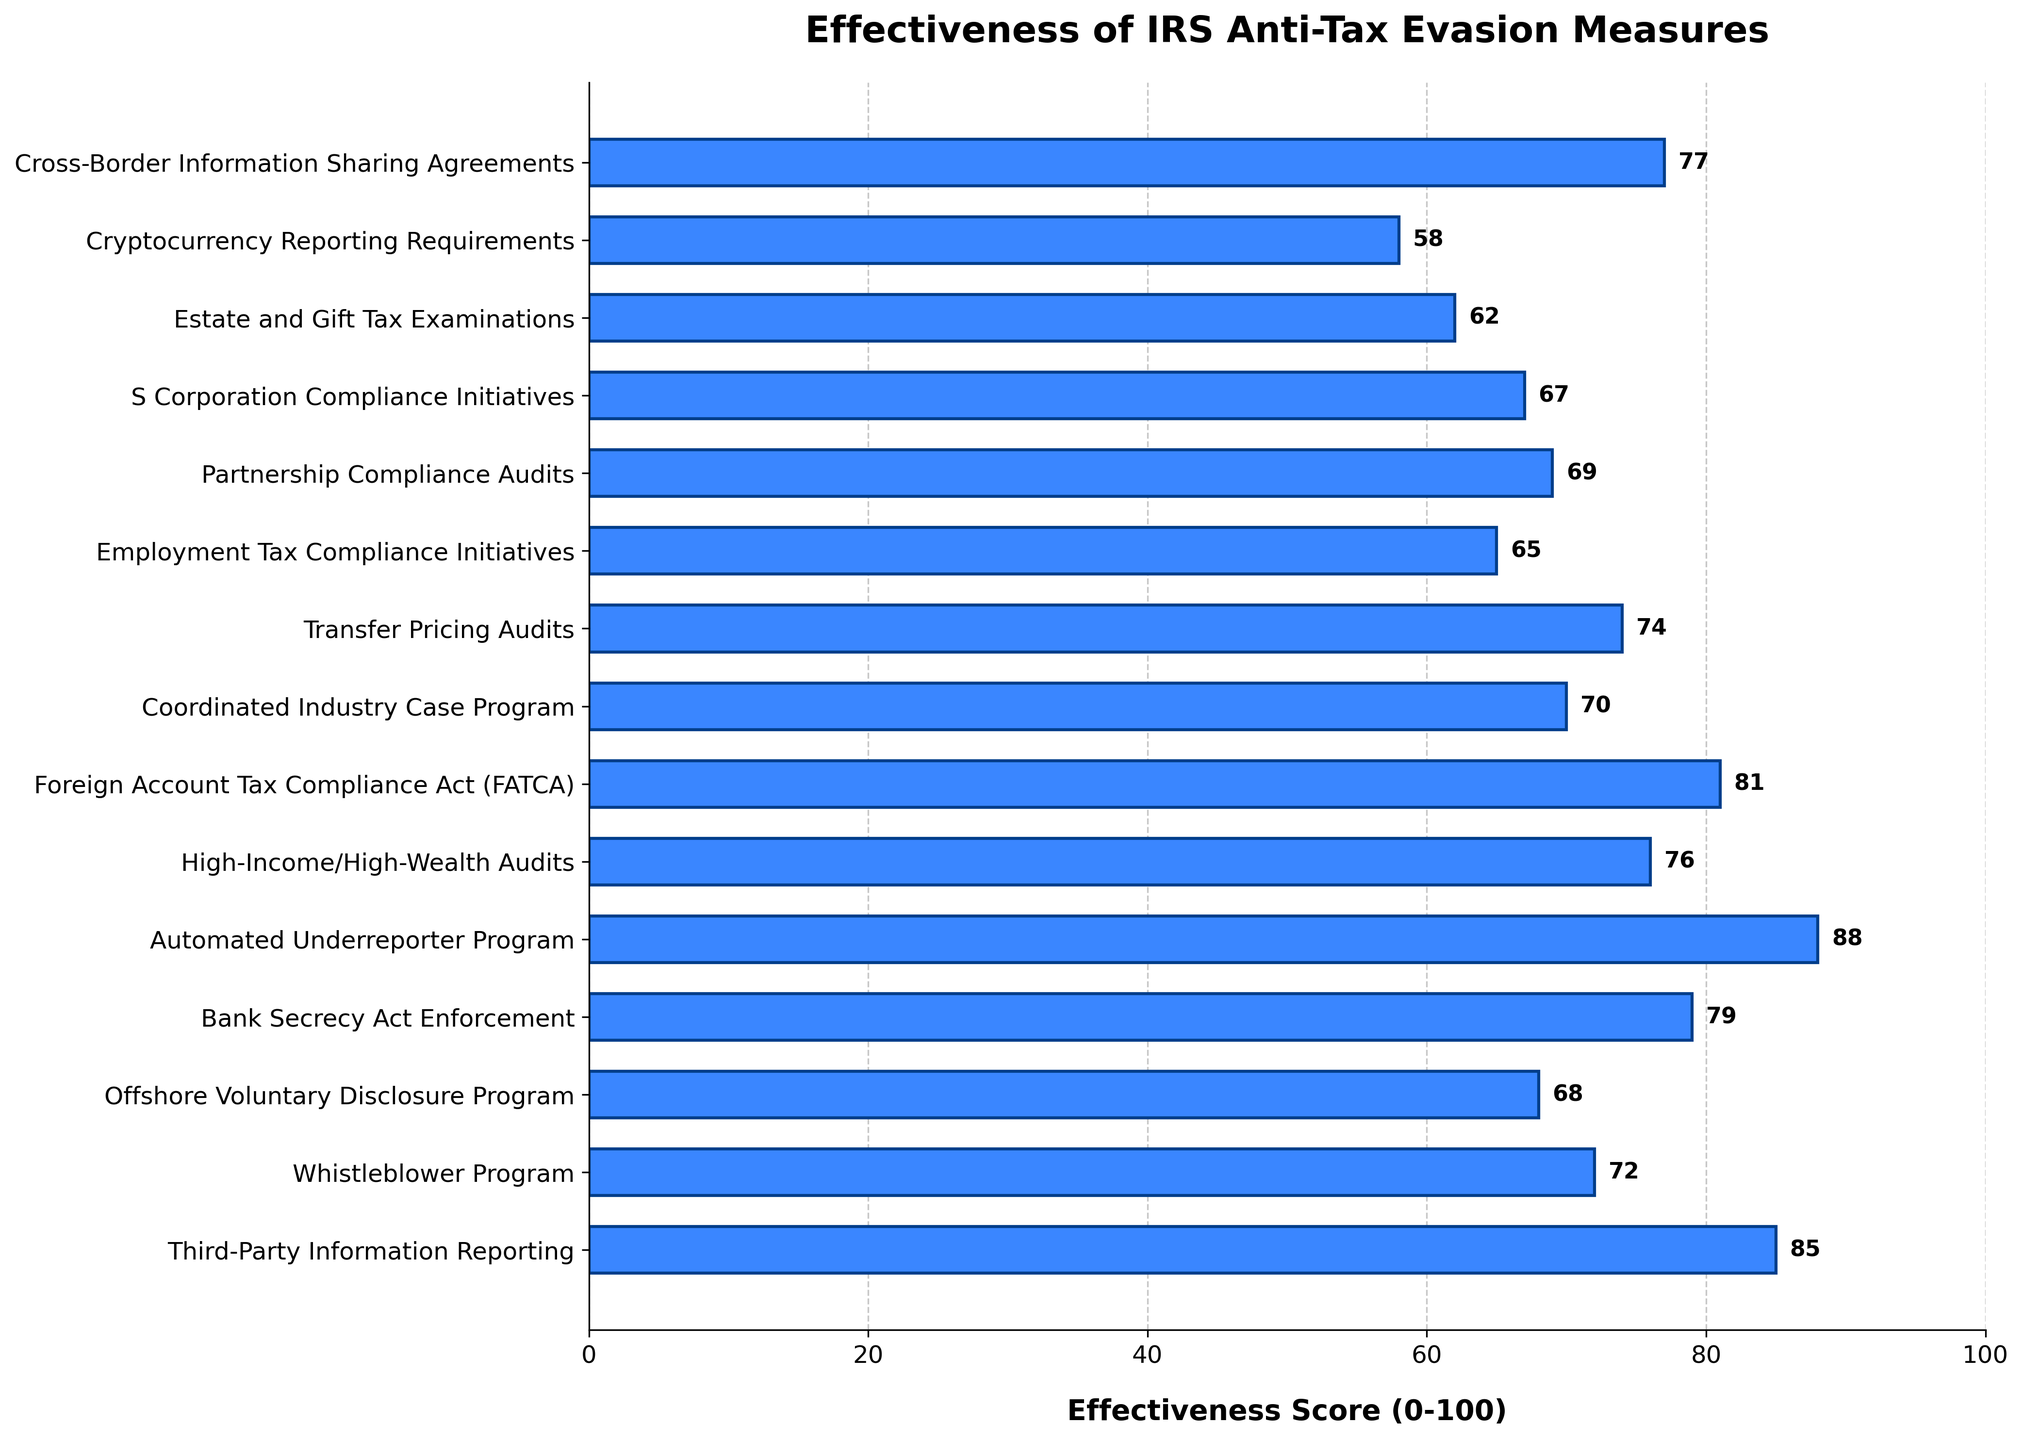What's the most effective IRS anti-tax evasion measure? The highest bar represents the most effective measure. The Automated Underreporter Program has an effectiveness score of 88, which is the highest among all the measures.
Answer: Automated Underreporter Program Which measure has a higher effectiveness score: Bank Secrecy Act Enforcement or Cross-Border Information Sharing Agreements? Refer to the bars corresponding to these measures. Bank Secrecy Act Enforcement has a score of 79, while Cross-Border Information Sharing Agreements has a score of 77.
Answer: Bank Secrecy Act Enforcement What is the average effectiveness score of all the measures listed in the chart? To calculate the average, sum all the effectiveness scores and divide by the number of measures. The sum is (85 + 72 + 68 + 79 + 88 + 76 + 81 + 70 + 74 + 65 + 69 + 67 + 62 + 58 + 77) = 1091. There are 15 measures, so the average score is 1091/15 ≈ 72.73
Answer: 72.73 Which measure is just below the Foreign Account Tax Compliance Act (FATCA) in terms of effectiveness score? Find the measure with the score just below FATCA's 81. Cross-Border Information Sharing Agreements, with a score of 77, is immediately below FATCA.
Answer: Cross-Border Information Sharing Agreements How many measures have an effectiveness score greater than 70? Count the number of measures with effectiveness scores higher than 70. They are: Third-Party Information Reporting (85), Whistleblower Program (72), Offshore Voluntary Disclosure Program (68), Bank Secrecy Act Enforcement (79), Automated Underreporter Program (88), High-Income/High-Wealth Audits (76), Foreign Account Tax Compliance Act (81), and Cross-Border Information Sharing Agreements (77). Eight measures total 8 scores higher than 70.
Answer: 8 What is the sum of the effectiveness scores for the three least effective measures? Identify the measures with the lowest effectiveness scores and sum them up. They are Cryptocurrency Reporting Requirements (58), Estate and Gift Tax Examinations (62), and Employment Tax Compliance Initiatives (65). The sum is (58 + 62 + 65) = 185.
Answer: 185 Which measure has the closest effectiveness score to the average effectiveness score of all measures? The calculated average effectiveness score is approximately 72.73. The closest score to this is the Whistleblower Program, which has an effectiveness score of 72.
Answer: Whistleblower Program Between Third-Party Information Reporting and Coordinated Industry Case Program, which measure has a larger effectiveness score, and by how much? Compare the effectiveness scores of Third-Party Information Reporting (85) and Coordinated Industry Case Program (70). The difference is 85 - 70 = 15.
Answer: Third-Party Information Reporting by 15 What is the effectiveness score of the measure with the shortest bar in the chart? The shortest bar represents the measure with the lowest effectiveness score, which is Cryptocurrency Reporting Requirements with a score of 58.
Answer: 58 